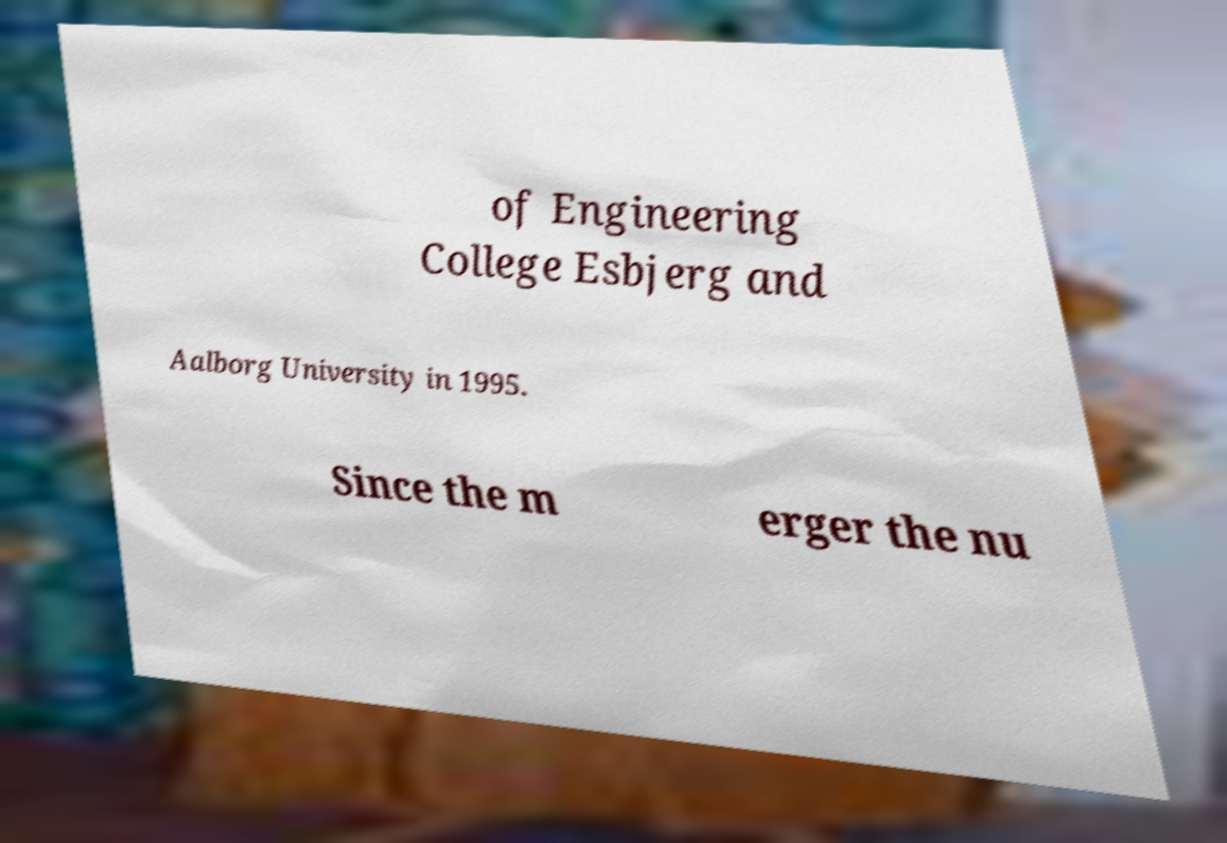Can you accurately transcribe the text from the provided image for me? of Engineering College Esbjerg and Aalborg University in 1995. Since the m erger the nu 